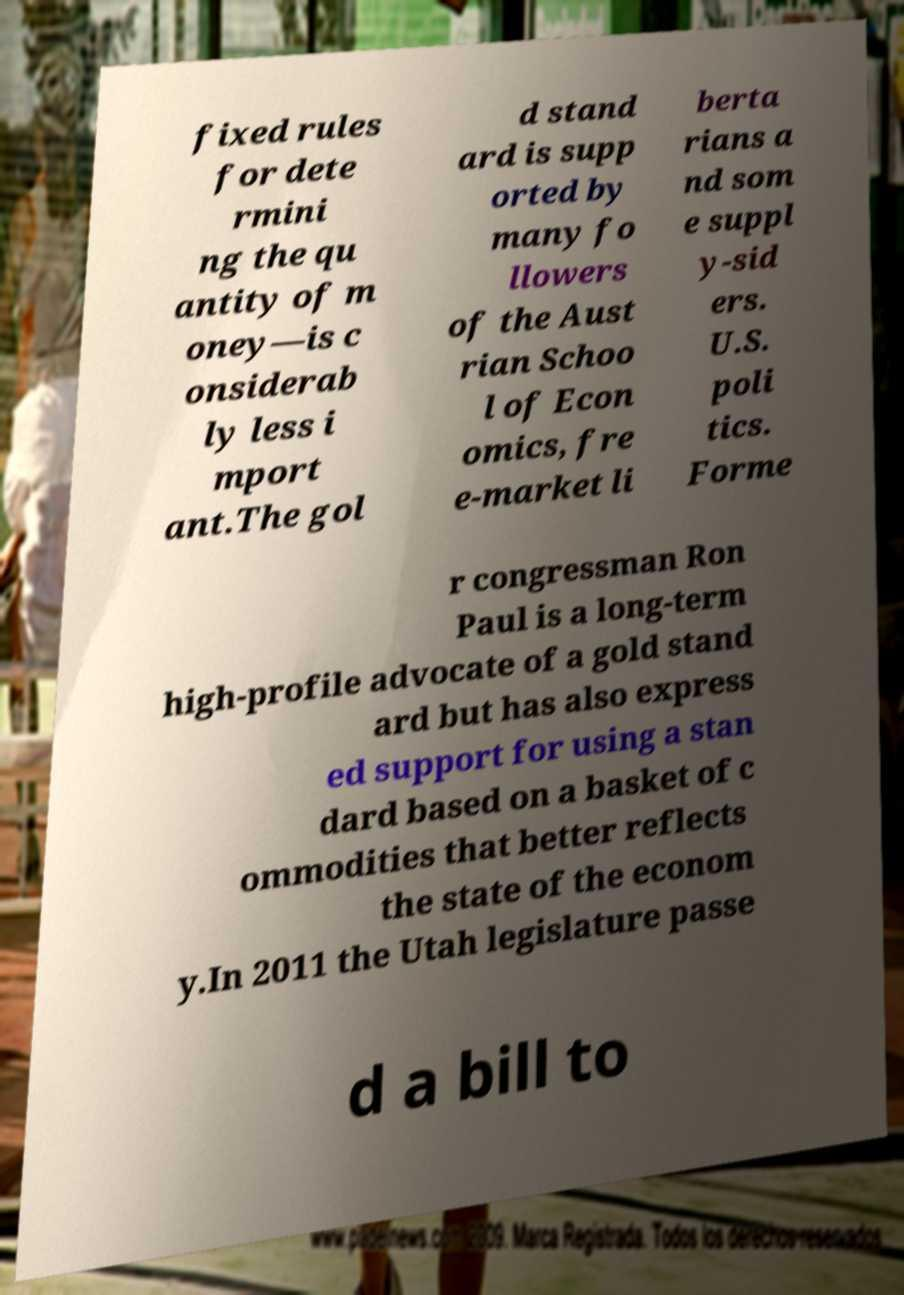Could you assist in decoding the text presented in this image and type it out clearly? fixed rules for dete rmini ng the qu antity of m oney—is c onsiderab ly less i mport ant.The gol d stand ard is supp orted by many fo llowers of the Aust rian Schoo l of Econ omics, fre e-market li berta rians a nd som e suppl y-sid ers. U.S. poli tics. Forme r congressman Ron Paul is a long-term high-profile advocate of a gold stand ard but has also express ed support for using a stan dard based on a basket of c ommodities that better reflects the state of the econom y.In 2011 the Utah legislature passe d a bill to 